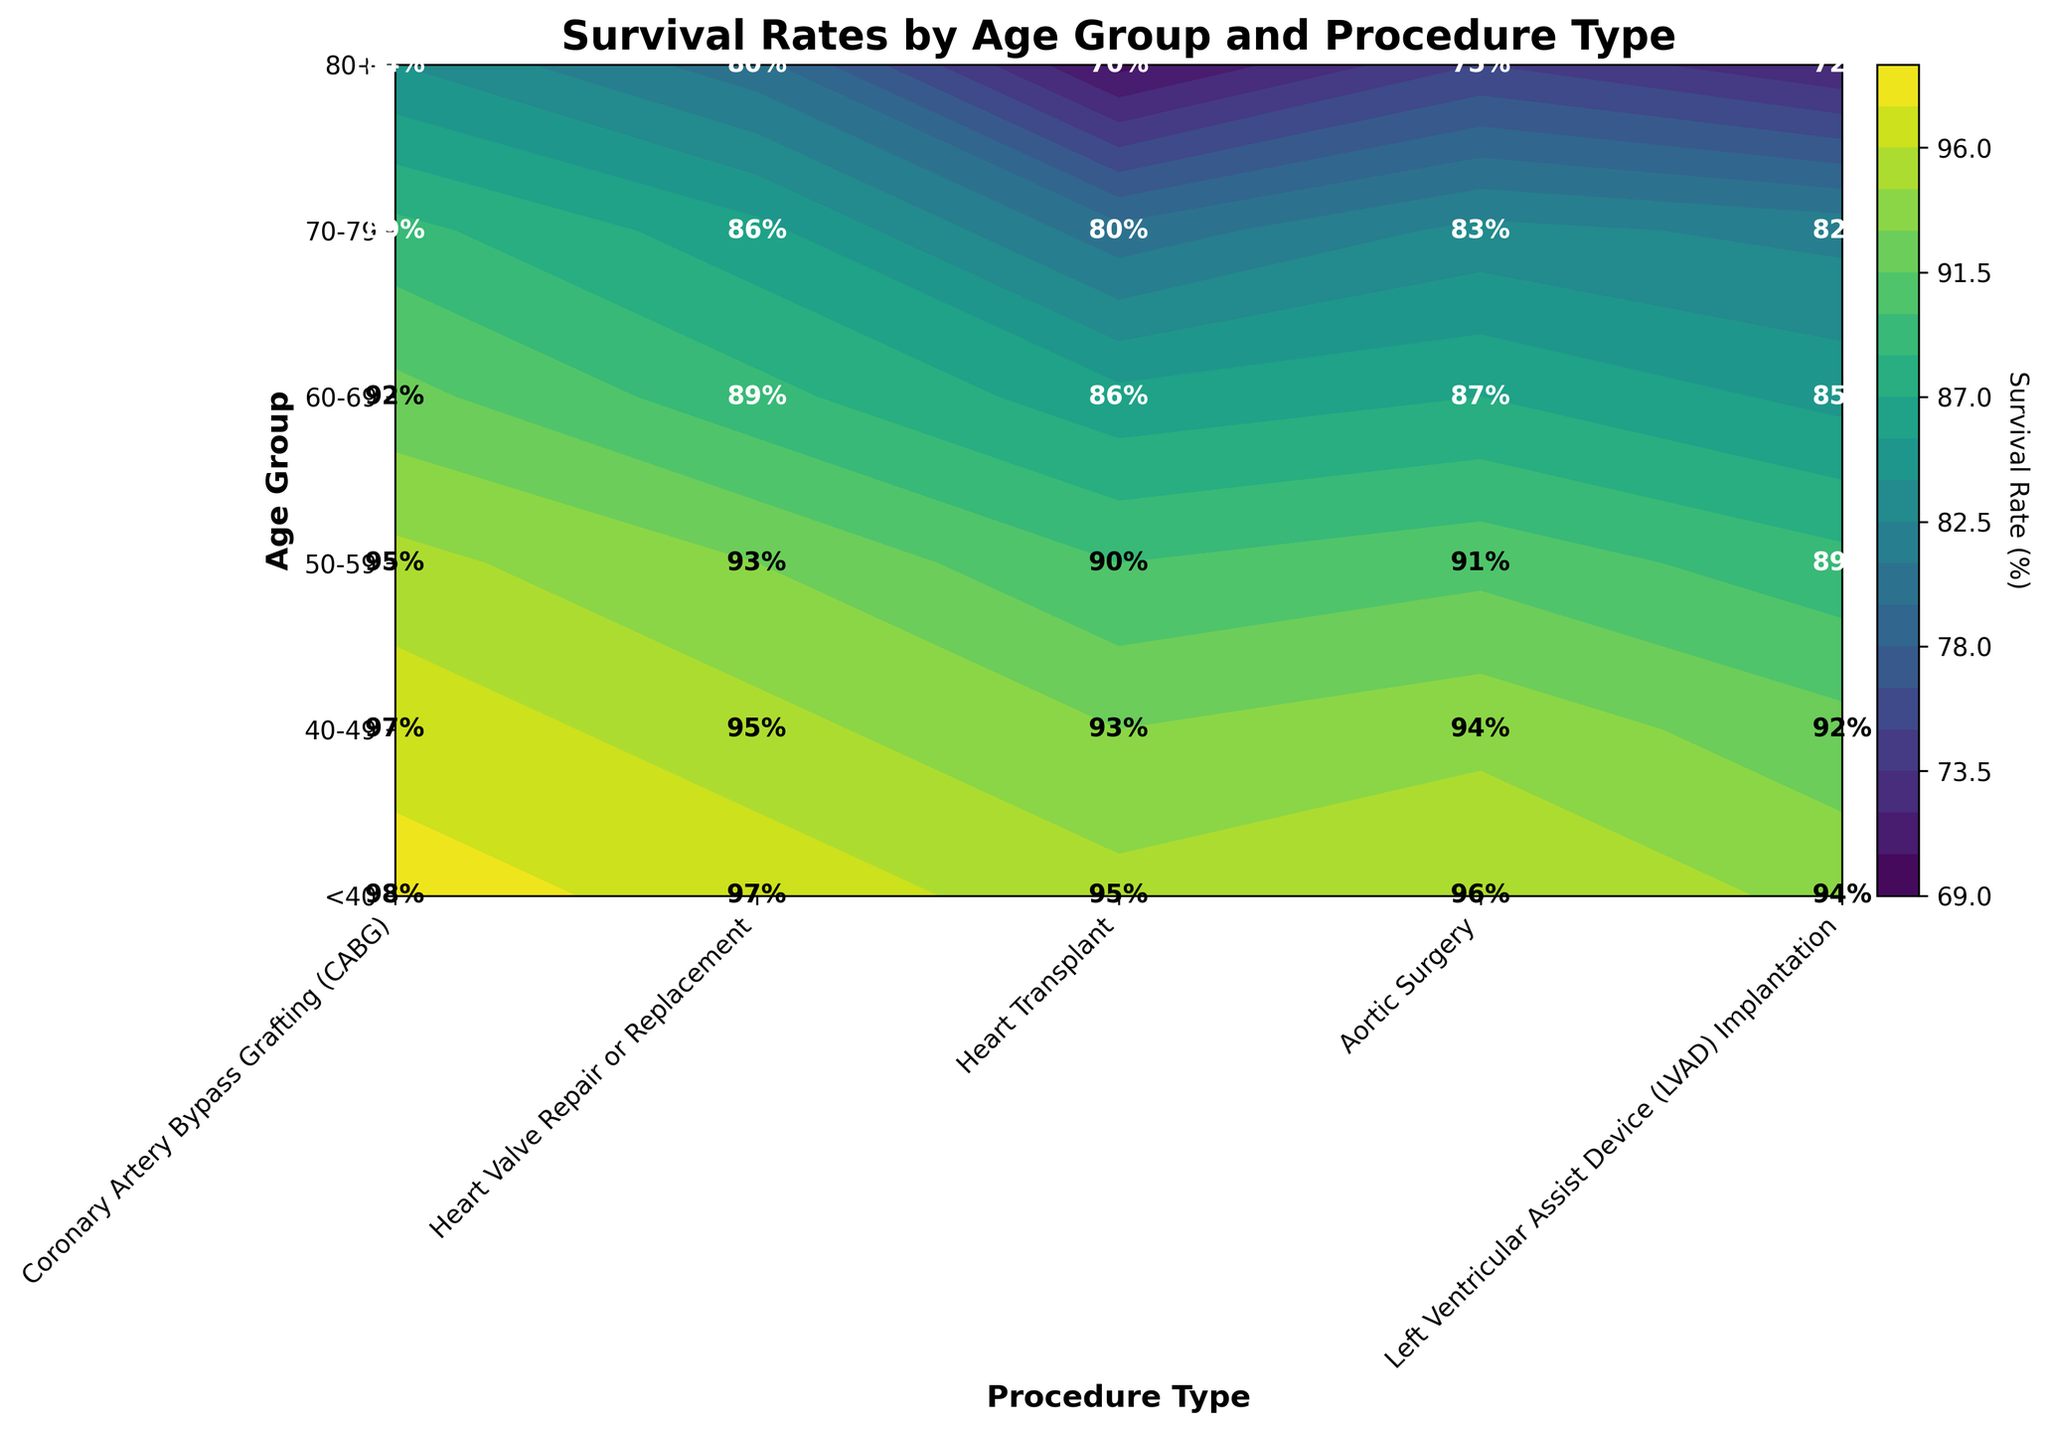What is the title of the plot? The title of the plot is displayed prominently at the top of the figure. It reads "Survival Rates by Age Group and Procedure Type".
Answer: Survival Rates by Age Group and Procedure Type What is the survival rate for patients under 40 undergoing heart transplants? Locate the age group '<40' on the y-axis and the 'Heart Transplant' procedure on the x-axis, then find the corresponding cell in the contour plot. The exact value is annotated within the cell.
Answer: 95% Which age group has the lowest survival rate for Coronary Artery Bypass Grafting (CABG)? Identify the 'Coronary Artery Bypass Grafting (CABG)' column and then scan through each age group's row to find the minimum survival rate.
Answer: 80+ What is the difference in survival rate between heart valve repair and aortic surgery for the age group 50-59? Locate the row for the age group 50-59. Find the survival rates for 'Heart Valve Repair or Replacement' and 'Aortic Surgery' and compute the difference (93% - 91%).
Answer: 2% Which procedure has the most consistent survival rate across all age groups? Examine the contour levels in each column and observe the range of survival rates. 'Coronary Artery Bypass Grafting (CABG)' shows the smallest range (between 84% to 98%).
Answer: Coronary Artery Bypass Grafting (CABG) How does the survival rate trend for left ventricular assist device (LVAD) implantation as patients age? Compare the survival rates in the 'Left Ventricular Assist Device (LVAD) Implantation' column across all age groups, noting any increases or decreases. The trend shows a decrease as age increases.
Answer: Decreasing For the 60-69 age group, which procedure has the highest survival rate? Locate the row for the 60-69 age group and identify the highest value among the procedures. 'Coronary Artery Bypass Grafting (CABG)' has the highest survival rate in this row with 92%.
Answer: Coronary Artery Bypass Grafting (CABG) What is the promedio de la tasa de supervivencia para la cirugía aórtica en todos los grupos de edad? Calculate the average by summing the survival rates for aortic surgery across all age groups and then dividing by the number of age groups. (96 + 94 + 91 + 87 + 83 + 75) / 6 = 87.67
Answer: 87.67 